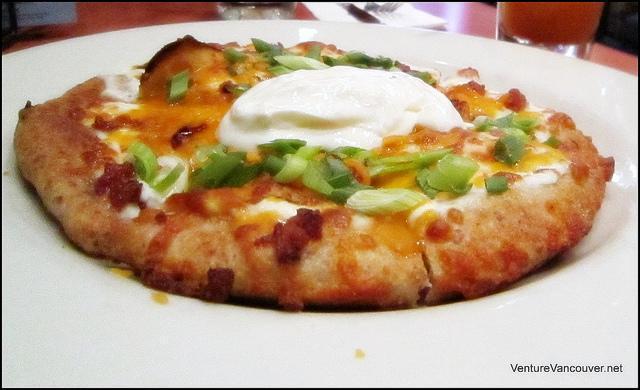How many people are on the elephant on the right?
Give a very brief answer. 0. 